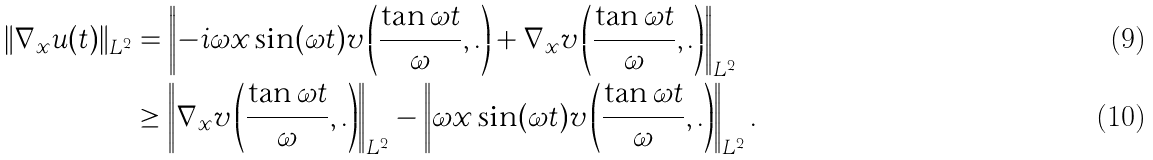<formula> <loc_0><loc_0><loc_500><loc_500>\| \nabla _ { x } u ( t ) \| _ { L ^ { 2 } } & = \left \| - i \omega x \sin ( \omega t ) v \left ( \frac { \tan \omega t } { \omega } , . \right ) + \nabla _ { x } v \left ( \frac { \tan \omega t } { \omega } , . \right ) \right \| _ { L ^ { 2 } } \\ & \geq \left \| \nabla _ { x } v \left ( \frac { \tan \omega t } { \omega } , . \right ) \right \| _ { L ^ { 2 } } - \left \| \omega x \sin ( \omega t ) v \left ( \frac { \tan \omega t } { \omega } , . \right ) \right \| _ { L ^ { 2 } } .</formula> 